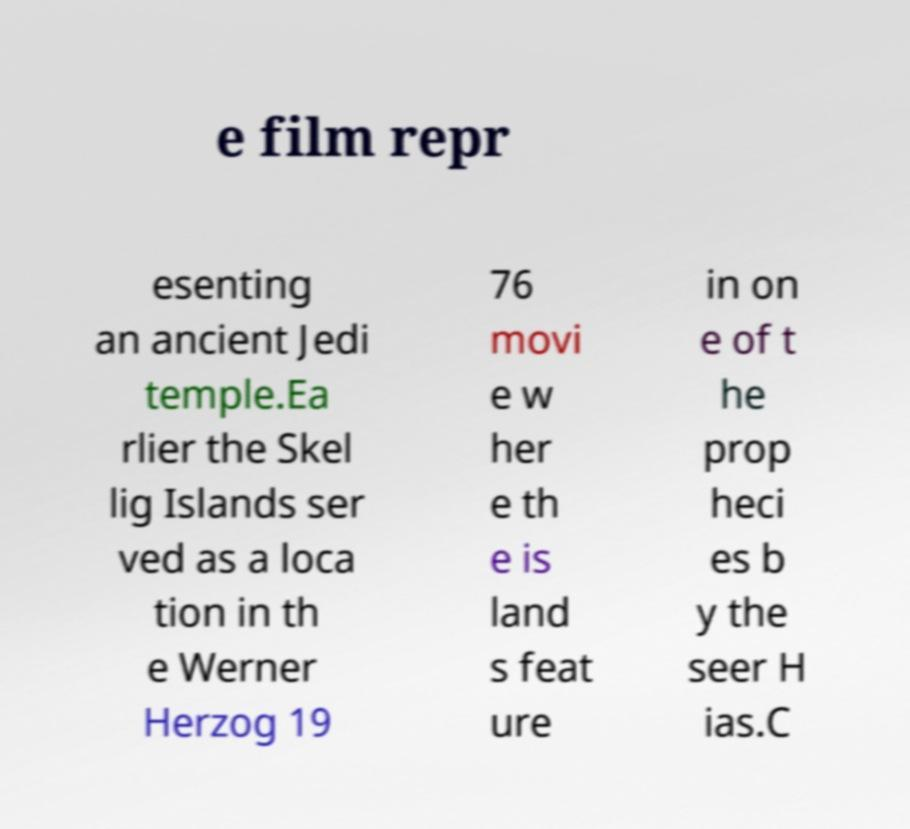I need the written content from this picture converted into text. Can you do that? e film repr esenting an ancient Jedi temple.Ea rlier the Skel lig Islands ser ved as a loca tion in th e Werner Herzog 19 76 movi e w her e th e is land s feat ure in on e of t he prop heci es b y the seer H ias.C 